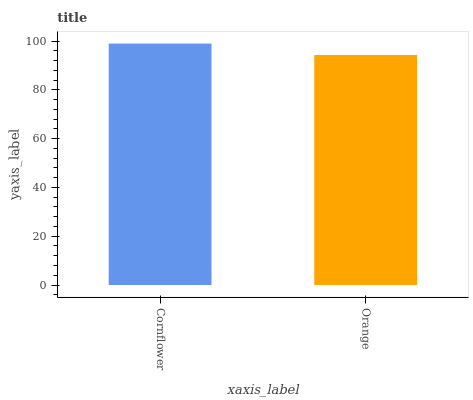Is Orange the maximum?
Answer yes or no. No. Is Cornflower greater than Orange?
Answer yes or no. Yes. Is Orange less than Cornflower?
Answer yes or no. Yes. Is Orange greater than Cornflower?
Answer yes or no. No. Is Cornflower less than Orange?
Answer yes or no. No. Is Cornflower the high median?
Answer yes or no. Yes. Is Orange the low median?
Answer yes or no. Yes. Is Orange the high median?
Answer yes or no. No. Is Cornflower the low median?
Answer yes or no. No. 